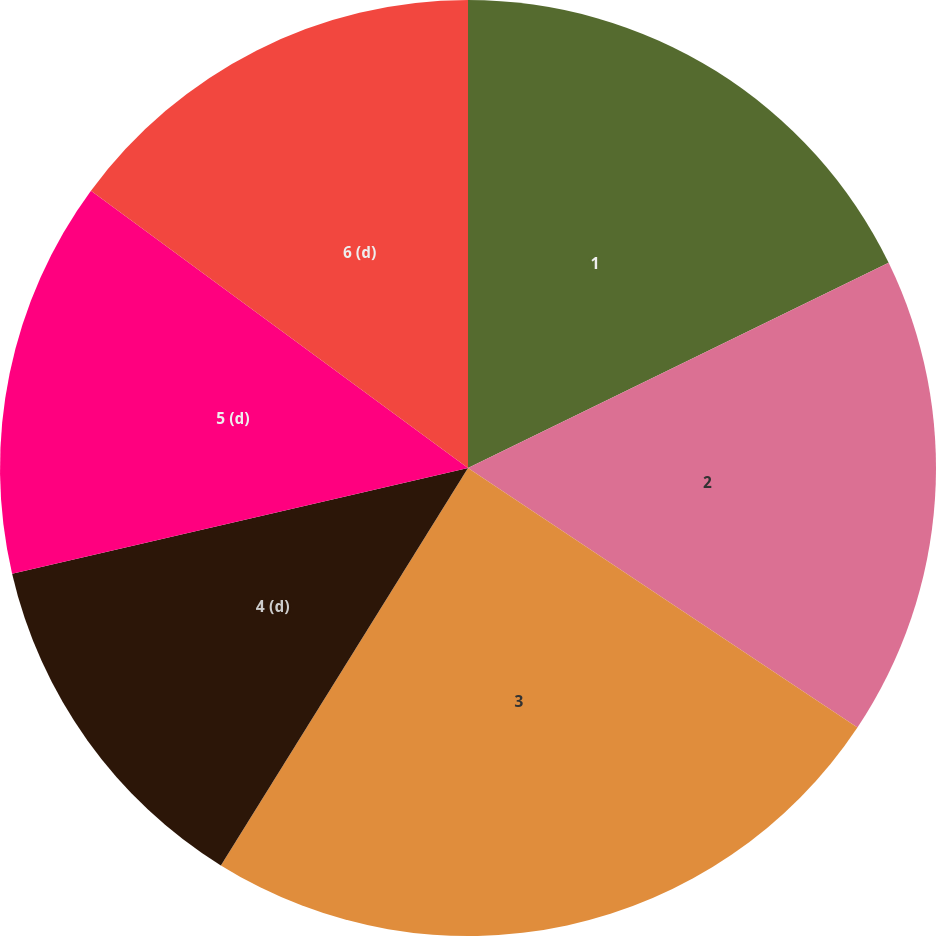Convert chart to OTSL. <chart><loc_0><loc_0><loc_500><loc_500><pie_chart><fcel>1<fcel>2<fcel>3<fcel>4 (d)<fcel>5 (d)<fcel>6 (d)<nl><fcel>17.78%<fcel>16.58%<fcel>24.5%<fcel>12.52%<fcel>13.72%<fcel>14.91%<nl></chart> 